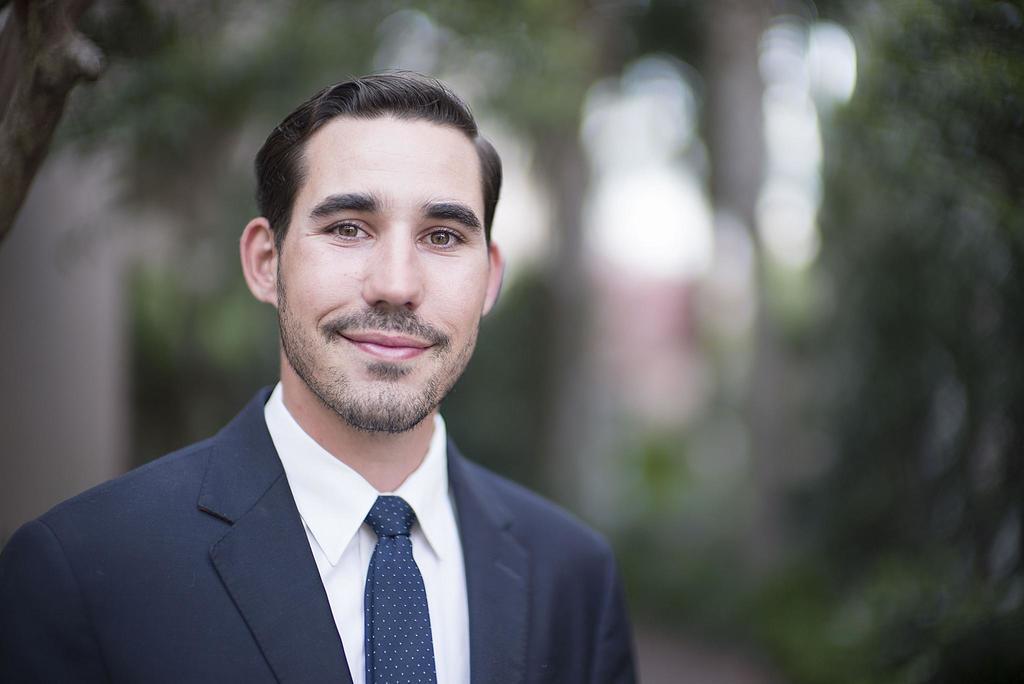In one or two sentences, can you explain what this image depicts? In this image there is a person truncated towards the bottom of the image, there is an object truncated towards the left of the image, the background of the image is blurred. 